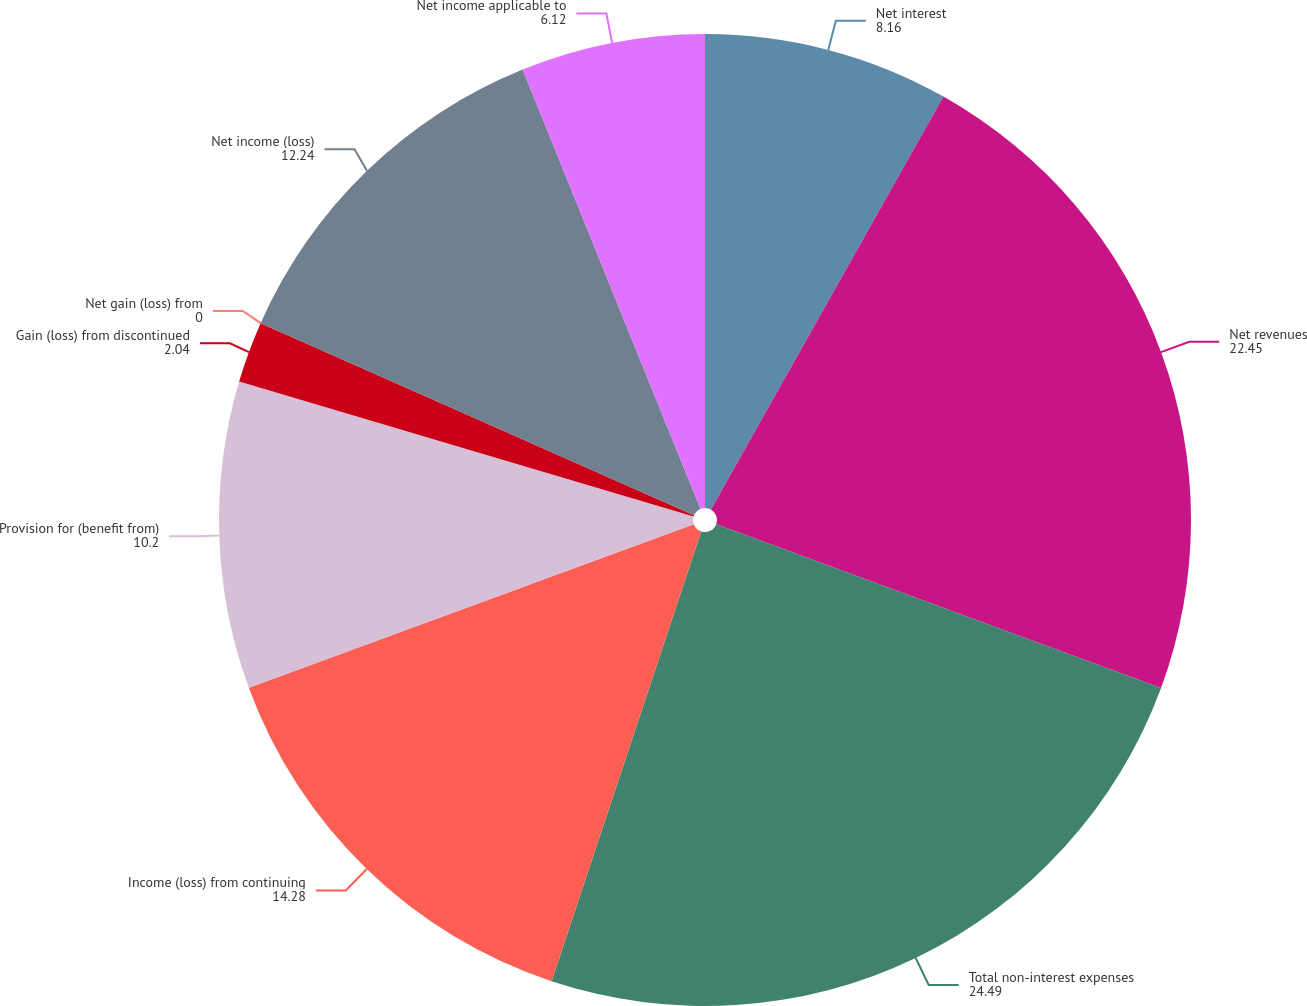Convert chart to OTSL. <chart><loc_0><loc_0><loc_500><loc_500><pie_chart><fcel>Net interest<fcel>Net revenues<fcel>Total non-interest expenses<fcel>Income (loss) from continuing<fcel>Provision for (benefit from)<fcel>Gain (loss) from discontinued<fcel>Net gain (loss) from<fcel>Net income (loss)<fcel>Net income applicable to<nl><fcel>8.16%<fcel>22.45%<fcel>24.49%<fcel>14.28%<fcel>10.2%<fcel>2.04%<fcel>0.0%<fcel>12.24%<fcel>6.12%<nl></chart> 